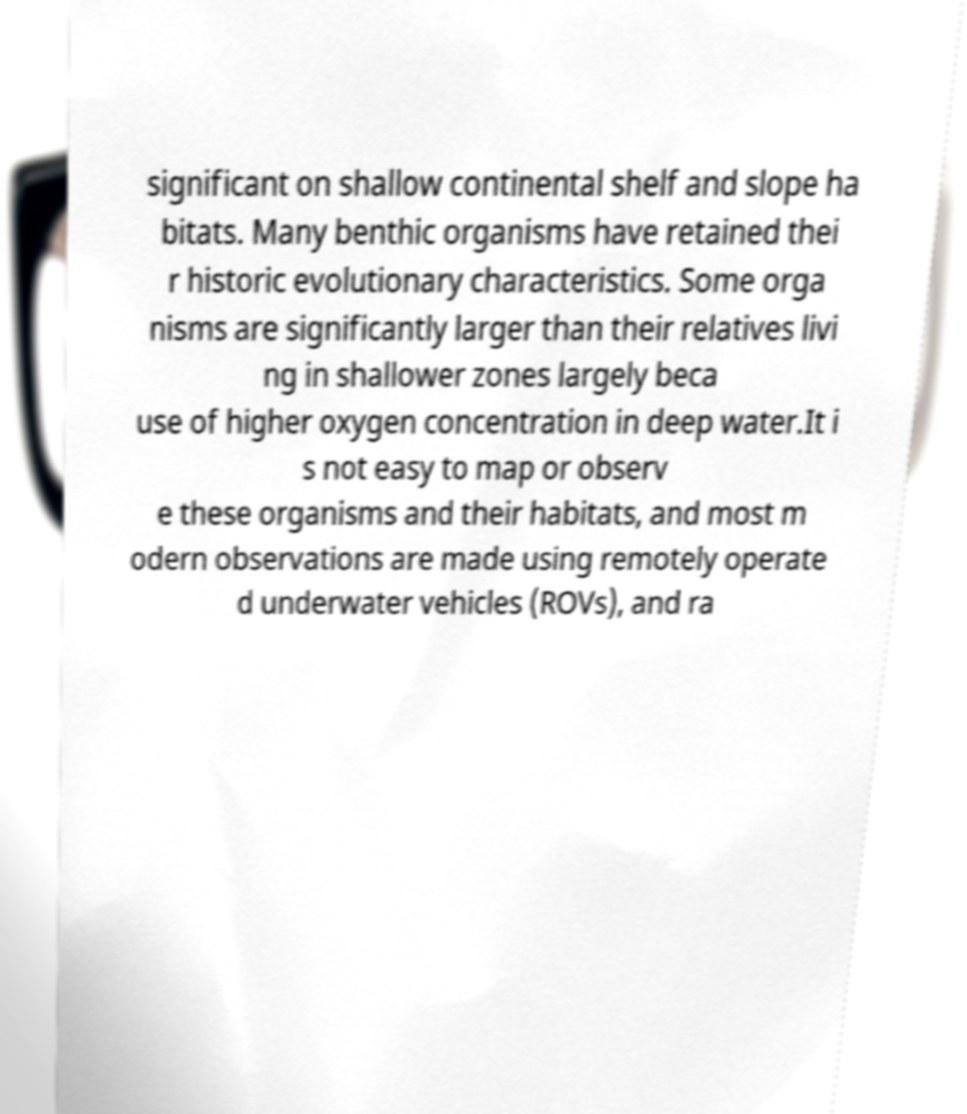What messages or text are displayed in this image? I need them in a readable, typed format. significant on shallow continental shelf and slope ha bitats. Many benthic organisms have retained thei r historic evolutionary characteristics. Some orga nisms are significantly larger than their relatives livi ng in shallower zones largely beca use of higher oxygen concentration in deep water.It i s not easy to map or observ e these organisms and their habitats, and most m odern observations are made using remotely operate d underwater vehicles (ROVs), and ra 